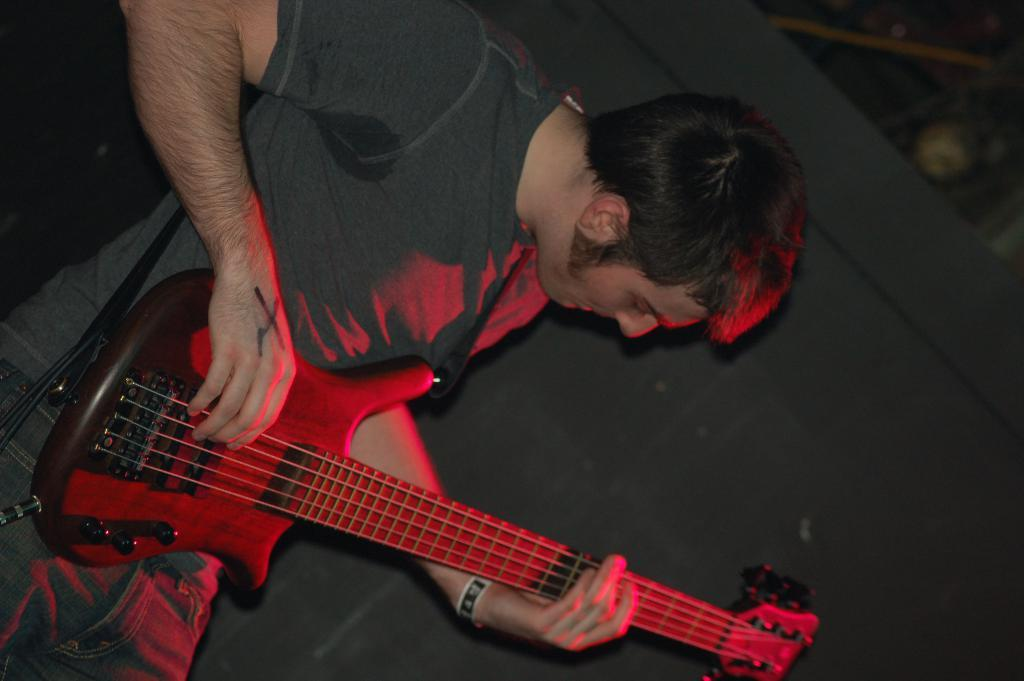What is the person in the image doing? The person is playing a guitar. What can be seen in the background of the image? There is a wall in the image. What type of writing is the person doing while playing the guitar? The person is not doing any writing in the image; they are solely focused on playing the guitar. 